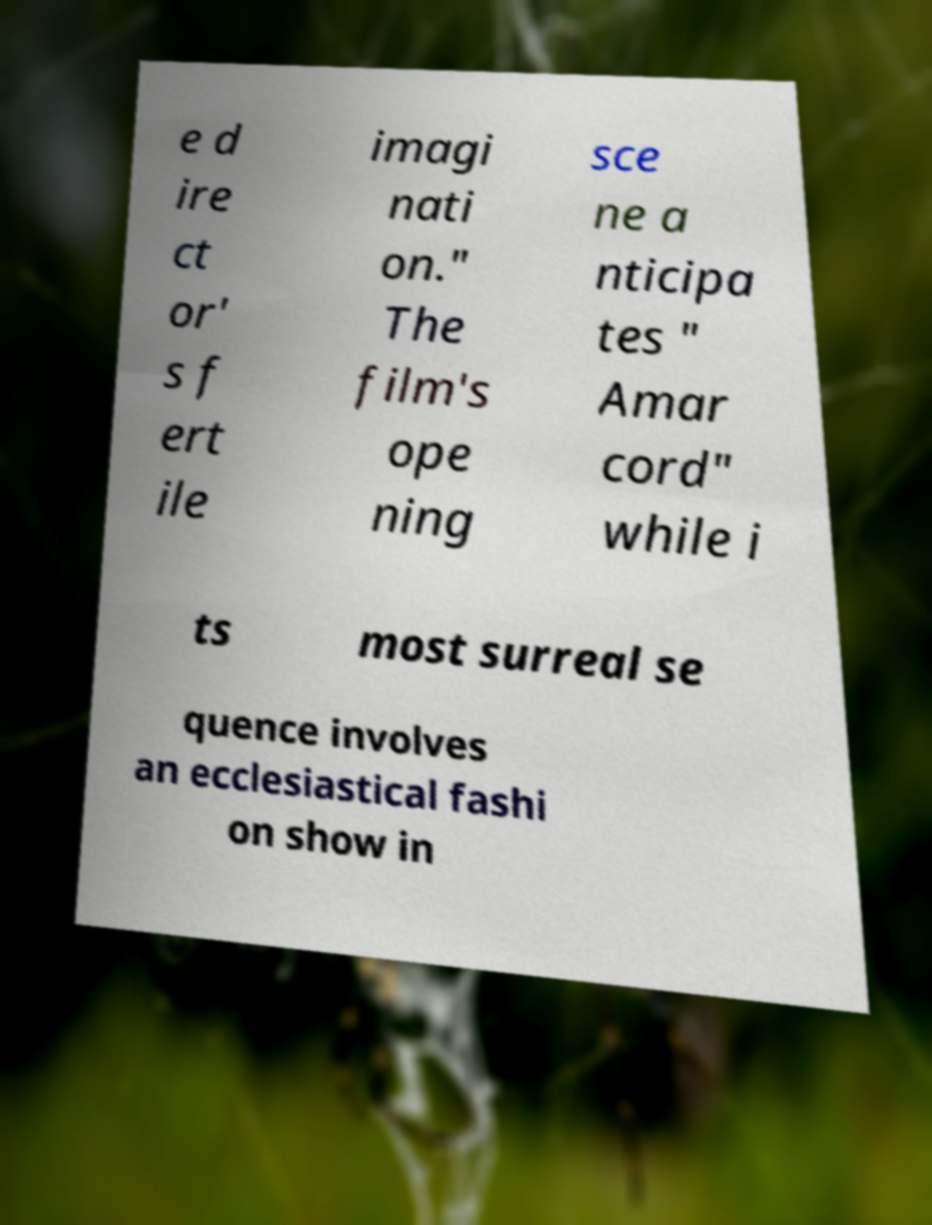Please read and relay the text visible in this image. What does it say? e d ire ct or' s f ert ile imagi nati on." The film's ope ning sce ne a nticipa tes " Amar cord" while i ts most surreal se quence involves an ecclesiastical fashi on show in 